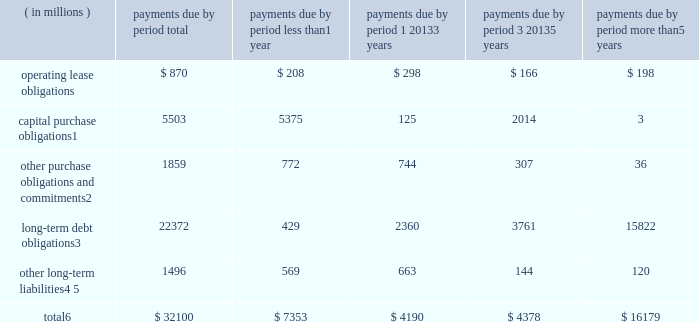Contractual obligations the table summarizes our significant contractual obligations as of december 28 , 2013: .
Capital purchase obligations1 5503 5375 125 2014 3 other purchase obligations and commitments2 1859 772 744 307 36 long-term debt obligations3 22372 429 2360 3761 15822 other long-term liabilities4 , 5 1496 569 663 144 120 total6 $ 32100 $ 7353 $ 4190 $ 4378 $ 16179 1 capital purchase obligations represent commitments for the construction or purchase of property , plant and equipment .
They were not recorded as liabilities on our consolidated balance sheets as of december 28 , 2013 , as we had not yet received the related goods or taken title to the property .
2 other purchase obligations and commitments include payments due under various types of licenses and agreements to purchase goods or services , as well as payments due under non-contingent funding obligations .
Funding obligations include agreements to fund various projects with other companies .
3 amounts represent principal and interest cash payments over the life of the debt obligations , including anticipated interest payments that are not recorded on our consolidated balance sheets .
Any future settlement of convertible debt would impact our cash payments .
4 we are unable to reliably estimate the timing of future payments related to uncertain tax positions ; therefore , $ 188 million of long-term income taxes payable has been excluded from the preceding table .
However , long- term income taxes payable , recorded on our consolidated balance sheets , included these uncertain tax positions , reduced by the associated federal deduction for state taxes and u.s .
Tax credits arising from non- u.s .
Income taxes .
5 amounts represent future cash payments to satisfy other long-term liabilities recorded on our consolidated balance sheets , including the short-term portion of these long-term liabilities .
Expected required contributions to our u.s .
And non-u.s .
Pension plans and other postretirement benefit plans of $ 62 million to be made during 2014 are also included ; however , funding projections beyond 2014 are not practicable to estimate .
6 total excludes contractual obligations already recorded on our consolidated balance sheets as current liabilities except for the short-term portions of long-term debt obligations and other long-term liabilities .
Contractual obligations for purchases of goods or services , included in other purchase obligations and commitments in the preceding table , include agreements that are enforceable and legally binding on intel and that specify all significant terms , including fixed or minimum quantities to be purchased ; fixed , minimum , or variable price provisions ; and the approximate timing of the transaction .
For obligations with cancellation provisions , the amounts included in the preceding table were limited to the non-cancelable portion of the agreement terms or the minimum cancellation fee .
We have entered into certain agreements for the purchase of raw materials that specify minimum prices and quantities based on a percentage of the total available market or based on a percentage of our future purchasing requirements .
Due to the uncertainty of the future market and our future purchasing requirements , as well as the non-binding nature of these agreements , obligations under these agreements are not included in the preceding table .
Our purchase orders for other products are based on our current manufacturing needs and are fulfilled by our vendors within short time horizons .
In addition , some of our purchase orders represent authorizations to purchase rather than binding agreements .
Table of contents management 2019s discussion and analysis of financial condition and results of operations ( continued ) .
What percentage of total contractual obligations as of december 28 , 2013 is made up of long-term debt obligations? 
Computations: (22372 / 32100)
Answer: 0.69695. 